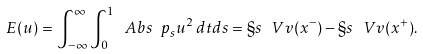Convert formula to latex. <formula><loc_0><loc_0><loc_500><loc_500>E ( u ) = \int _ { - \infty } ^ { \infty } \int _ { 0 } ^ { 1 } \ A b s { \ p _ { s } u } ^ { 2 } \, d t d s = \S s _ { \ } V v ( x ^ { - } ) - \S s _ { \ } V v ( x ^ { + } ) .</formula> 